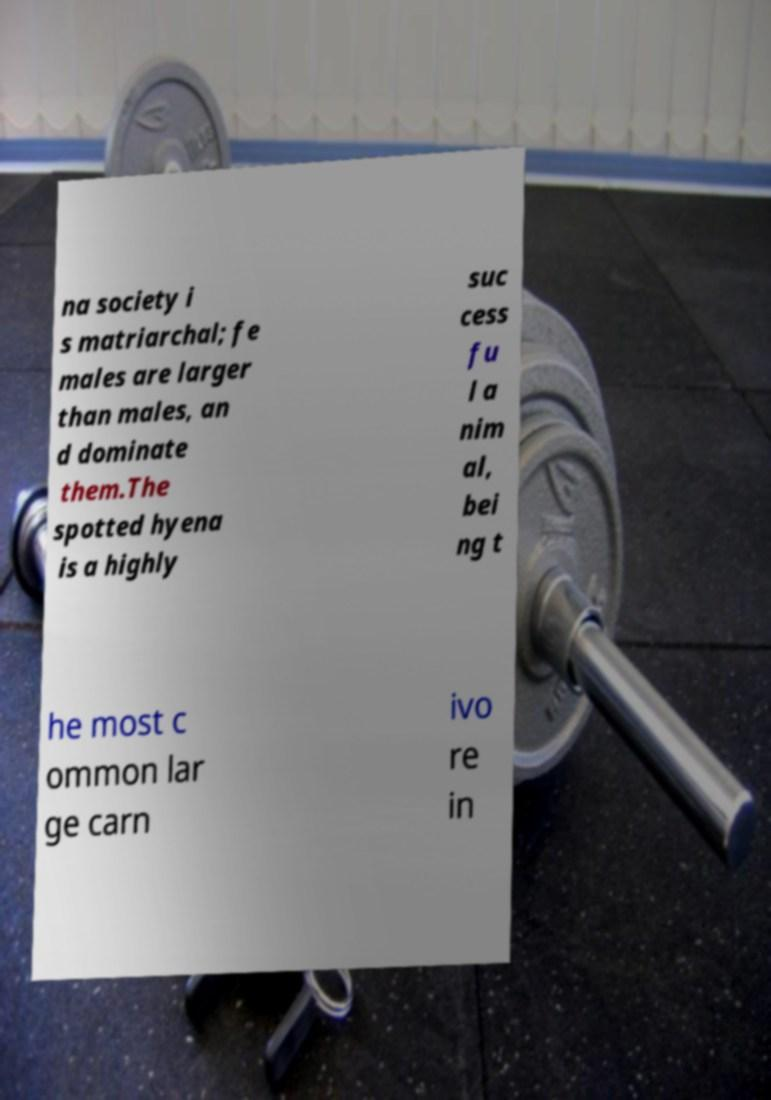What messages or text are displayed in this image? I need them in a readable, typed format. na society i s matriarchal; fe males are larger than males, an d dominate them.The spotted hyena is a highly suc cess fu l a nim al, bei ng t he most c ommon lar ge carn ivo re in 